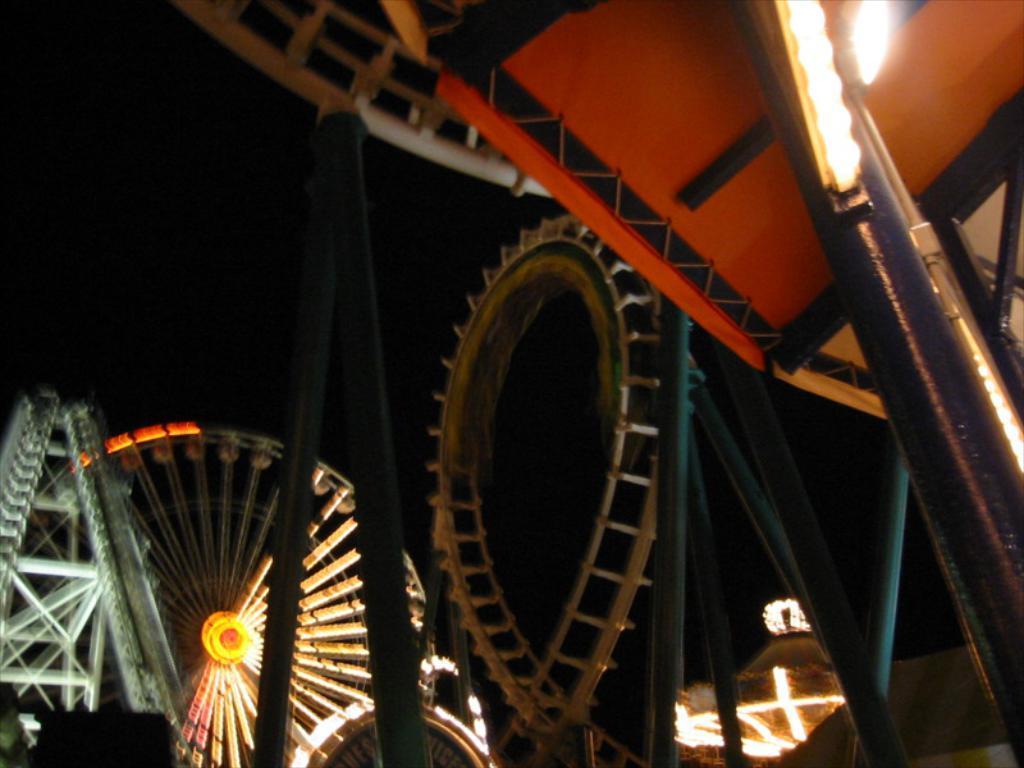Describe this image in one or two sentences. In this picture we can see amusement park rides, rods, lights and in the background it is dark. 